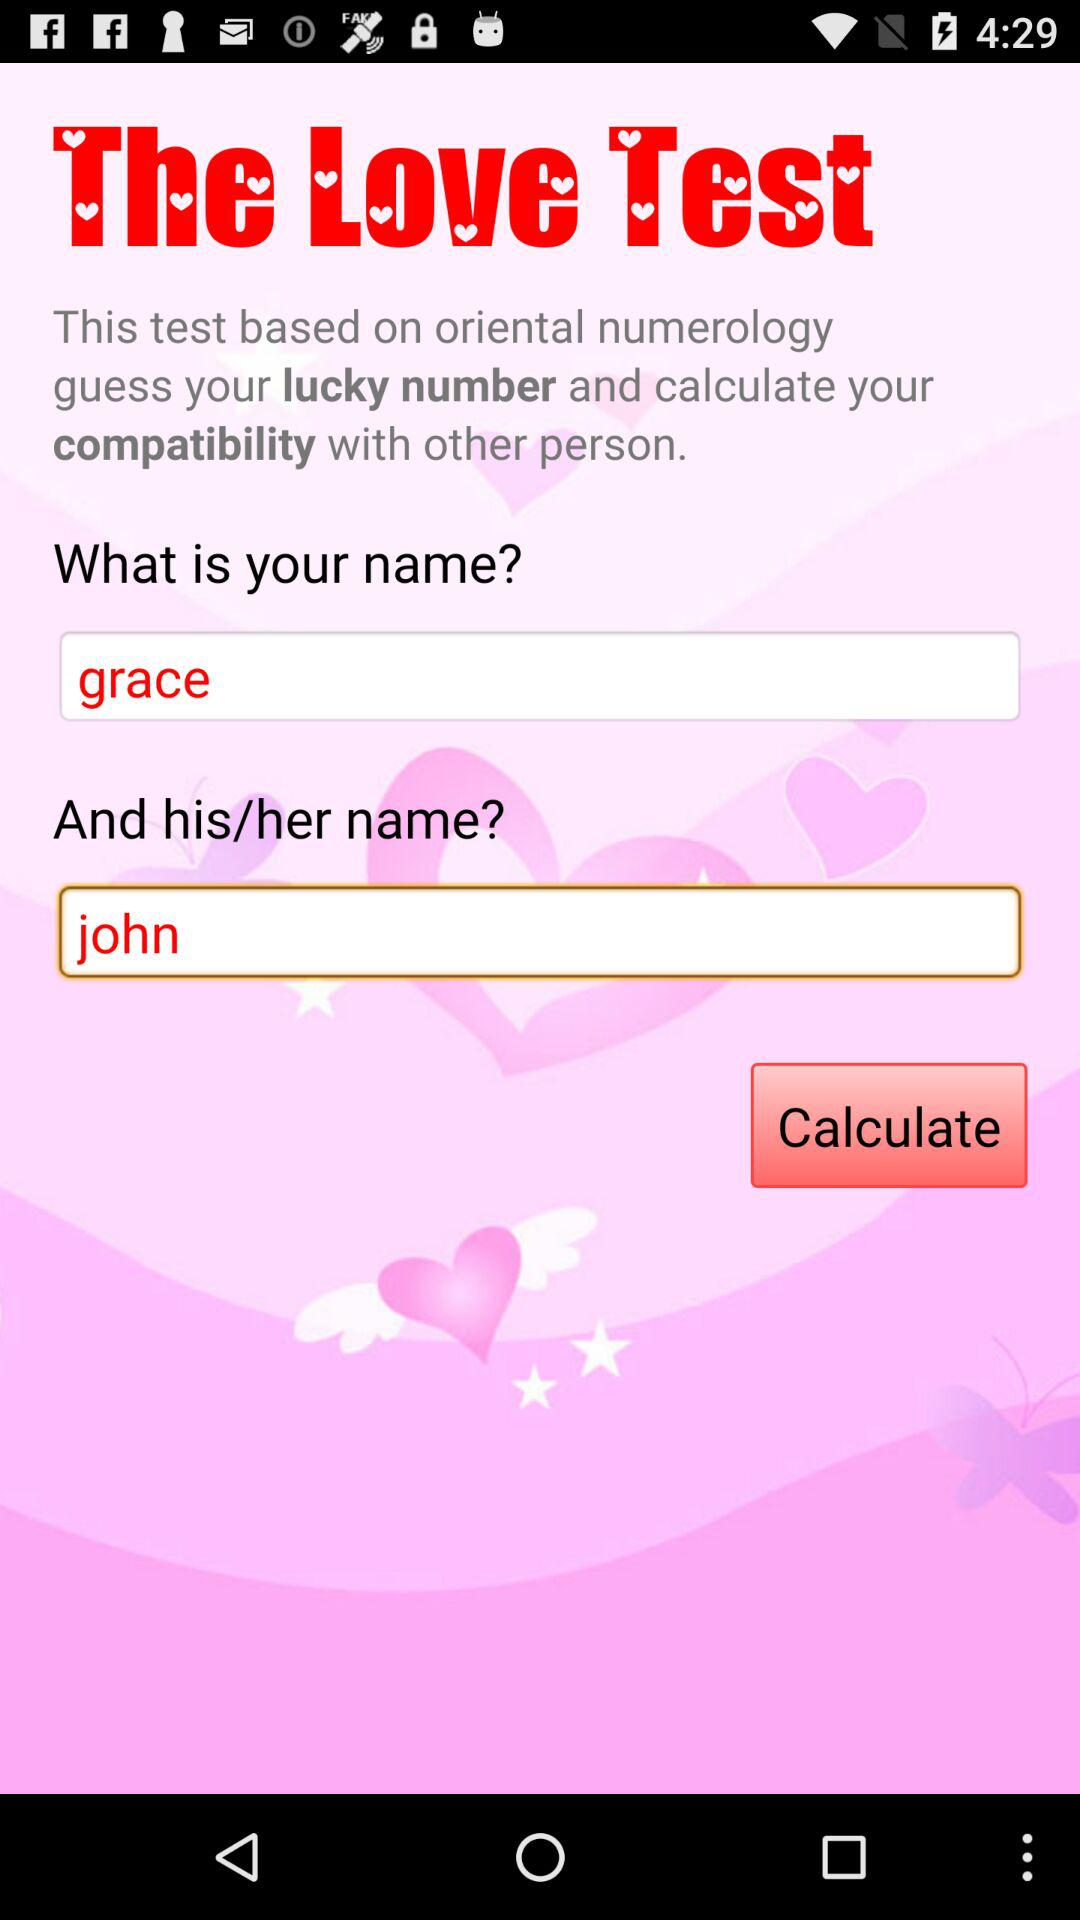How many text inputs are present on the screen?
Answer the question using a single word or phrase. 2 